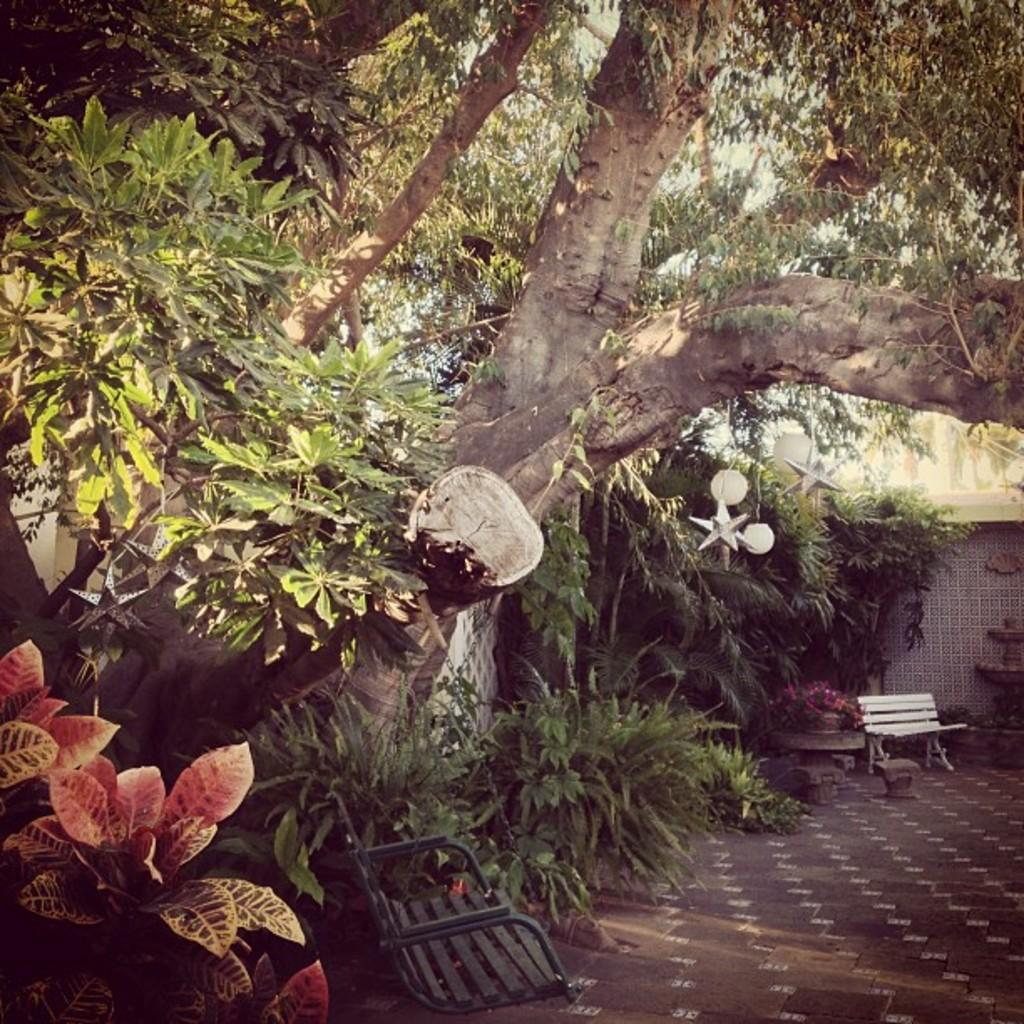What type of area is shown in the image? The image depicts a garden. What can be found in the garden? There are plants and trees in the garden. Are there any seating areas in the garden? Yes, there are benches in the garden. What is at the back of the garden? There is a wall at the back of the garden. What type of berry is growing on the low branches of the trees in the image? There are no berries mentioned or visible in the image, and the branches of the trees are not described as low. 